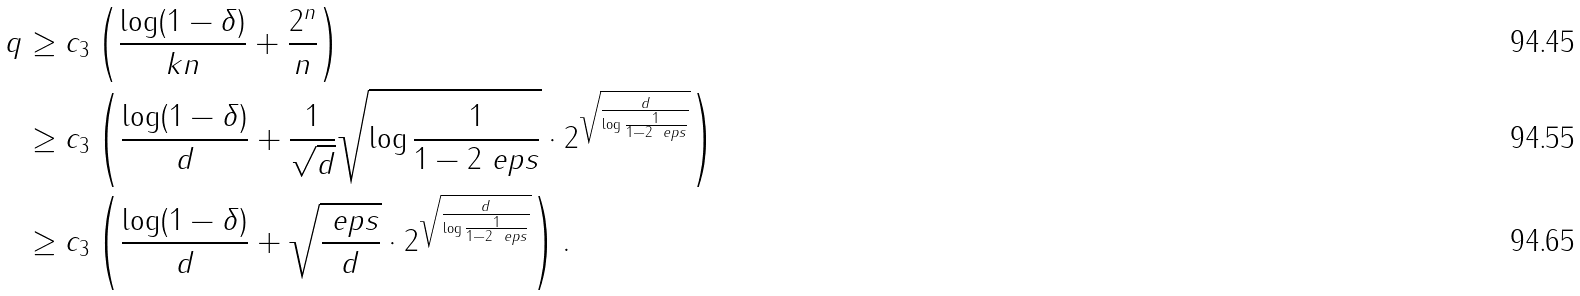<formula> <loc_0><loc_0><loc_500><loc_500>q & \geq c _ { 3 } \left ( \frac { \log ( 1 - \delta ) } { k n } + \frac { 2 ^ { n } } { n } \right ) \\ & \geq c _ { 3 } \left ( \frac { \log ( 1 - \delta ) } { d } + \frac { 1 } { \sqrt { d } } \sqrt { \log { \frac { 1 } { 1 - 2 \ e p s } } } \cdot 2 ^ { \sqrt { \frac { d } { \log { \frac { 1 } { 1 - 2 \ e p s } } } } } \right ) \\ & \geq c _ { 3 } \left ( \frac { \log ( 1 - \delta ) } { d } + \sqrt { \frac { \ e p s } { d } } \cdot 2 ^ { \sqrt { \frac { d } { \log { \frac { 1 } { 1 - 2 \ e p s } } } } } \right ) .</formula> 